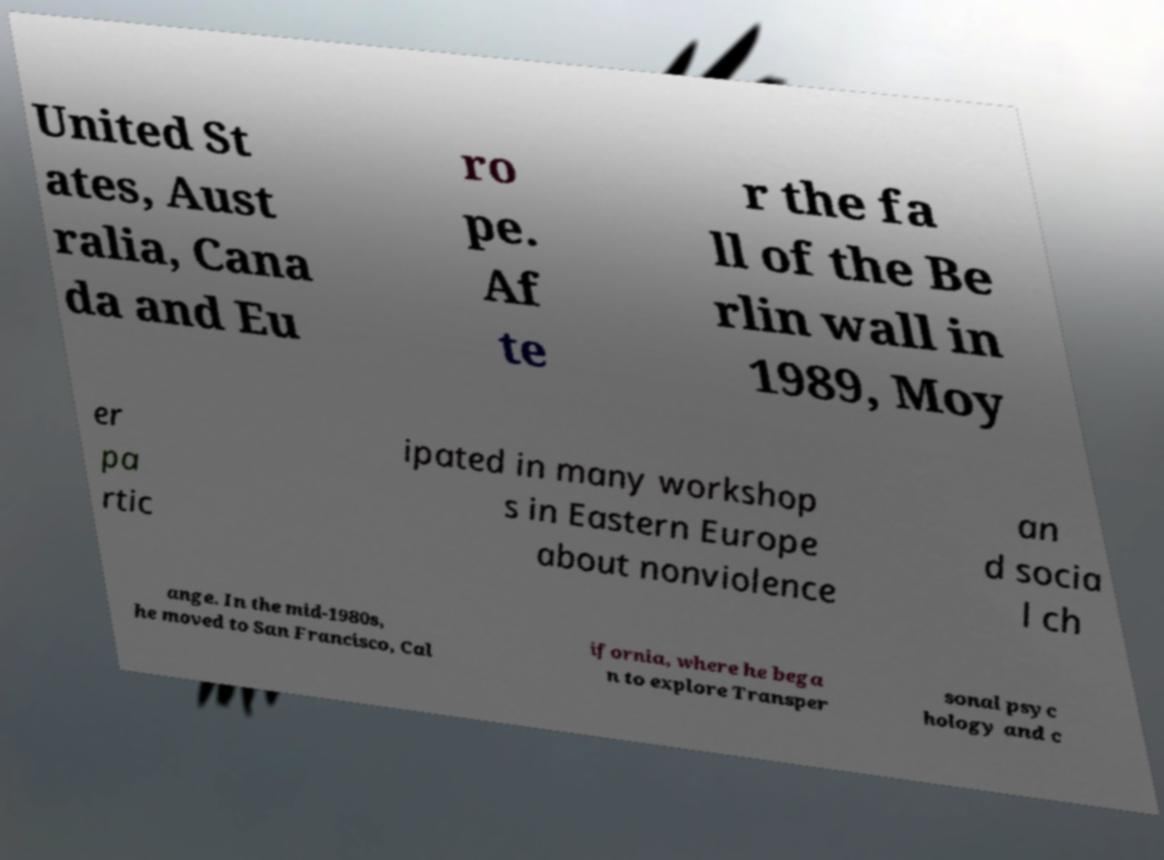Can you read and provide the text displayed in the image?This photo seems to have some interesting text. Can you extract and type it out for me? United St ates, Aust ralia, Cana da and Eu ro pe. Af te r the fa ll of the Be rlin wall in 1989, Moy er pa rtic ipated in many workshop s in Eastern Europe about nonviolence an d socia l ch ange. In the mid-1980s, he moved to San Francisco, Cal ifornia, where he bega n to explore Transper sonal psyc hology and c 